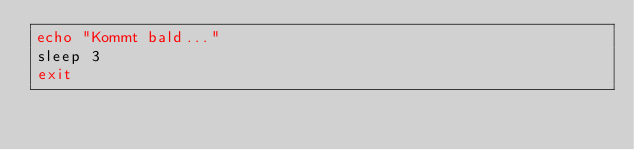<code> <loc_0><loc_0><loc_500><loc_500><_Bash_>echo "Kommt bald..."
sleep 3
exit</code> 